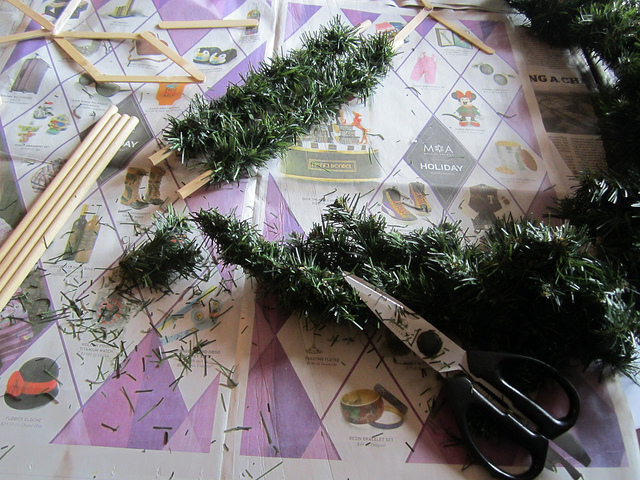Please extract the text content from this image. M*A HOLIDAY AY CH A NG 